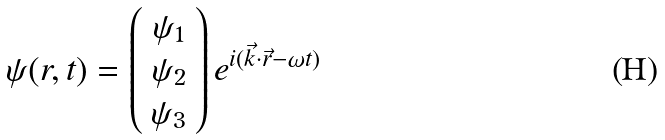Convert formula to latex. <formula><loc_0><loc_0><loc_500><loc_500>\psi ( r , t ) = \left ( \begin{array} { c } \psi _ { 1 } \\ \psi _ { 2 } \\ \psi _ { 3 } \end{array} \right ) e ^ { i ( \vec { k } \cdot \vec { r } - \omega t ) } \,</formula> 